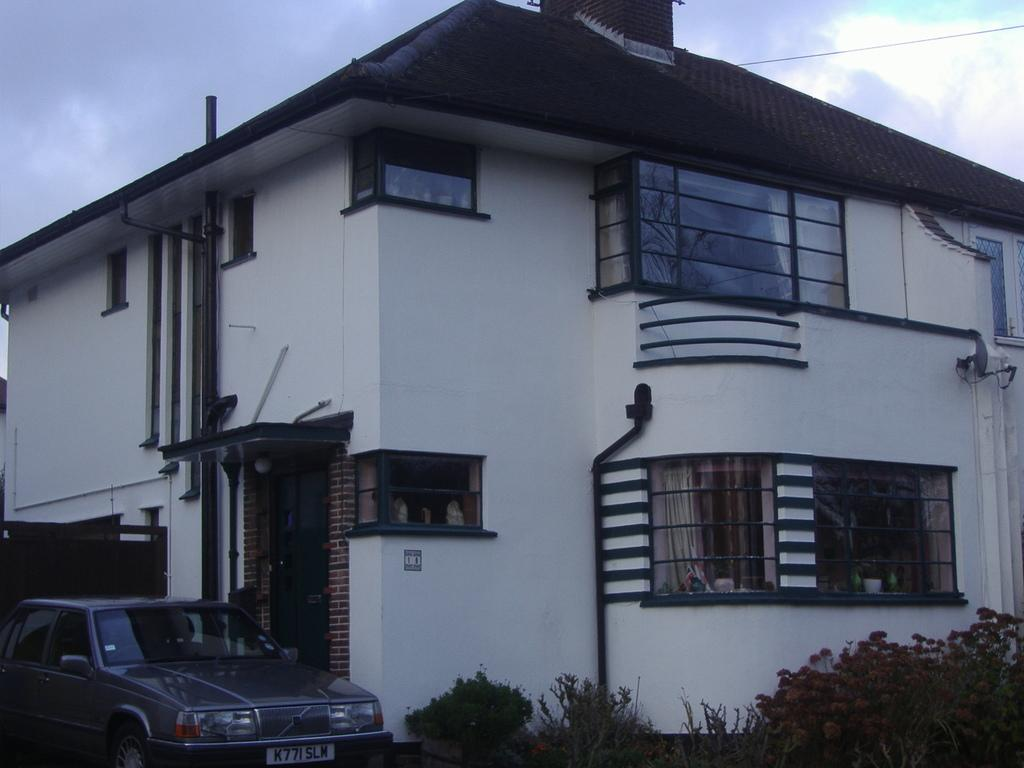What is the main subject of the image? There is a car in the image. What else can be seen in the image besides the car? There are plants, a building, and some objects in the image. What is the background of the image? The sky is visible in the background of the image. Can you see any land blowing in the wind in the image? There is no land blowing in the wind in the image. Is there a seashore visible in the image? There is no seashore present in the image. 